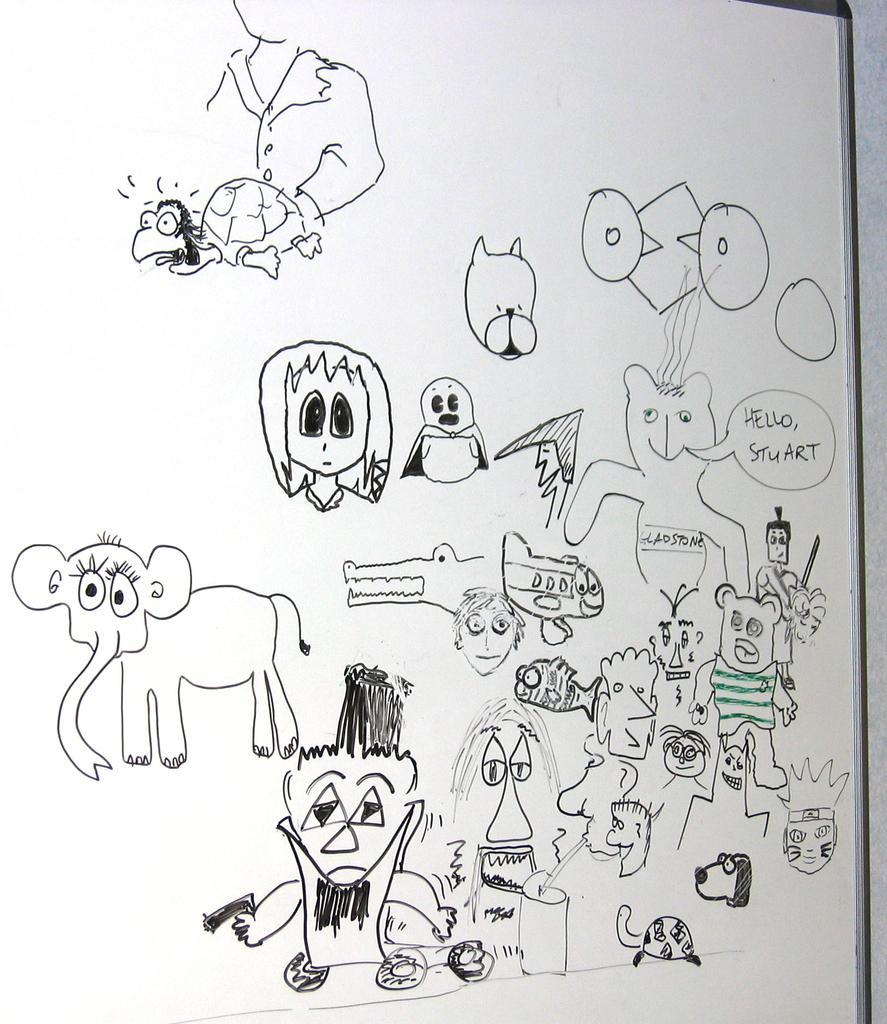Could you give a brief overview of what you see in this image? In this image we can see a board with drawings of animals and few other things. Also there is text on the board. 